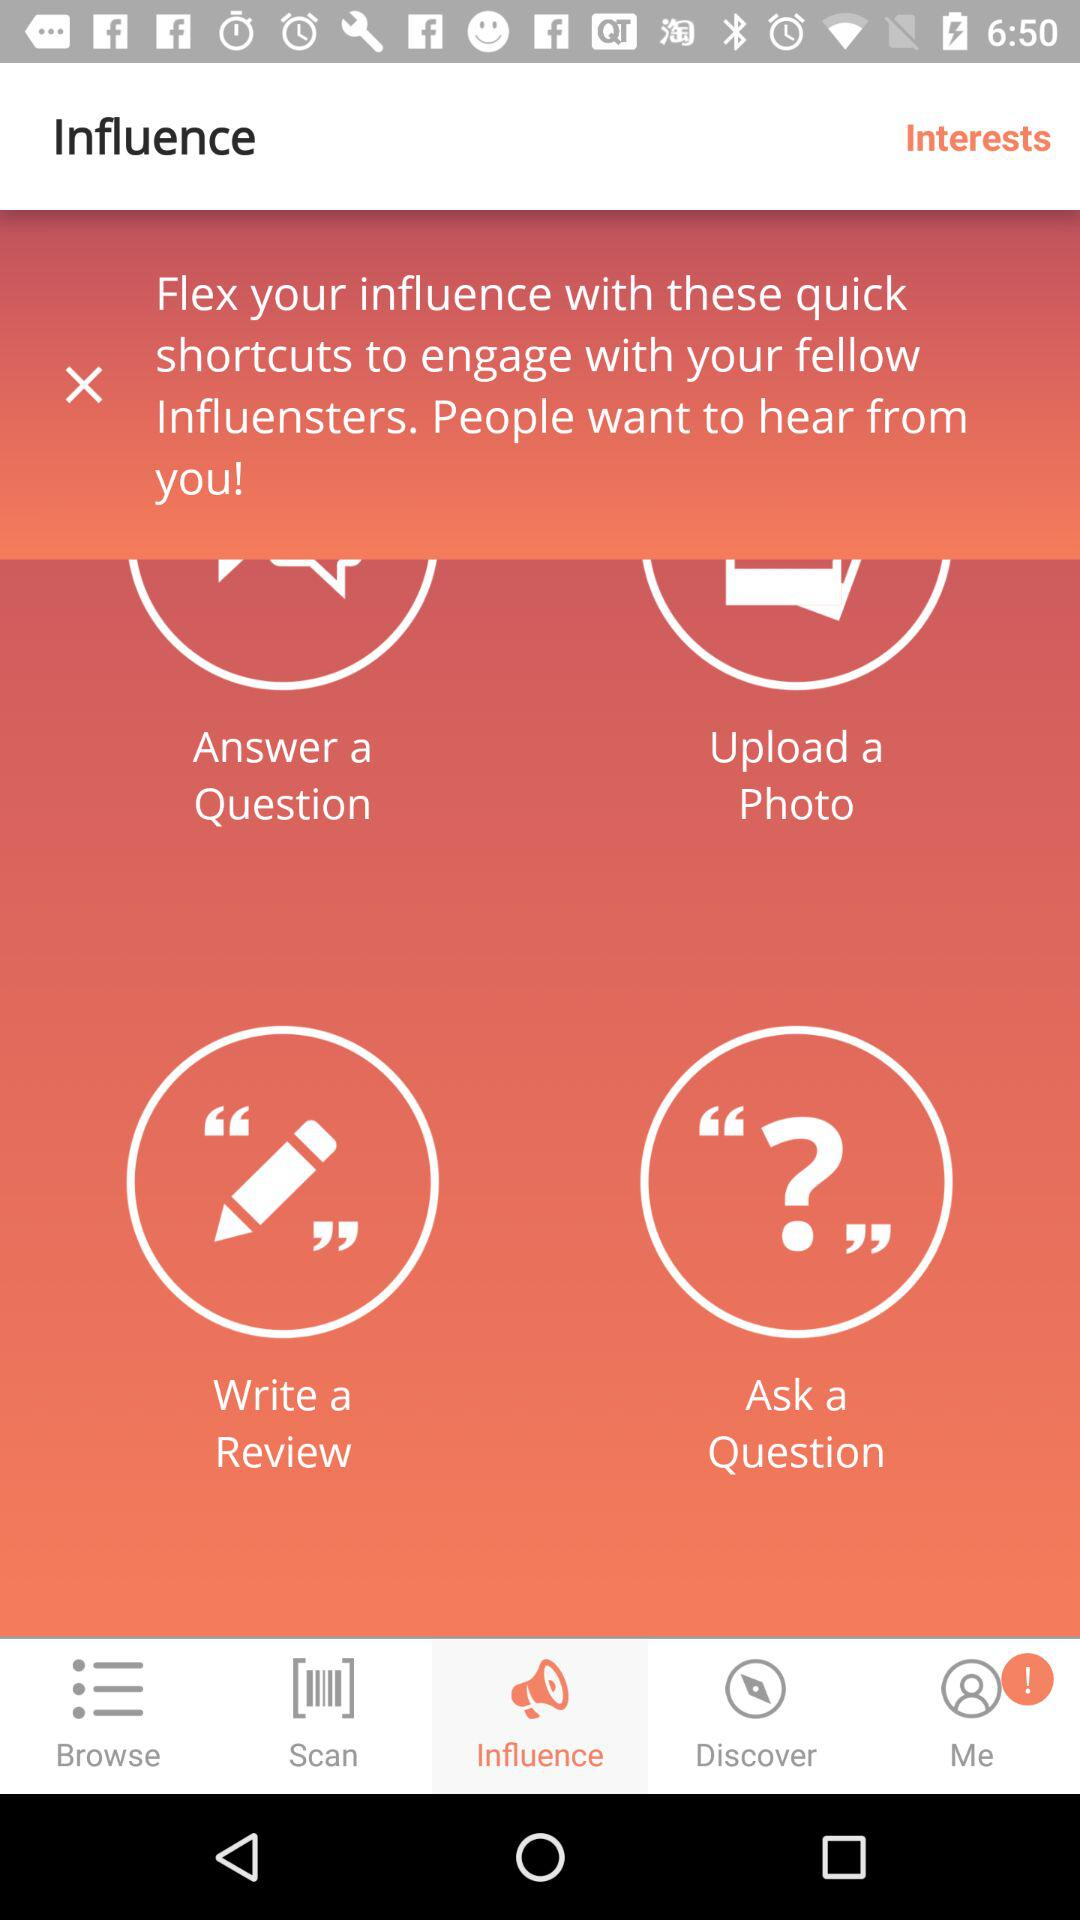Which option is currently selected in the bottom bar? The option that is currently selected in the bottom bar is "Influence". 